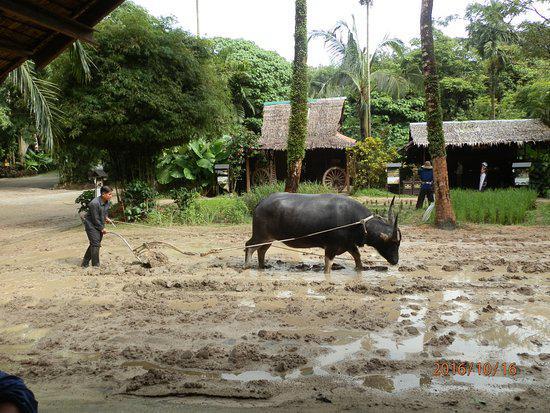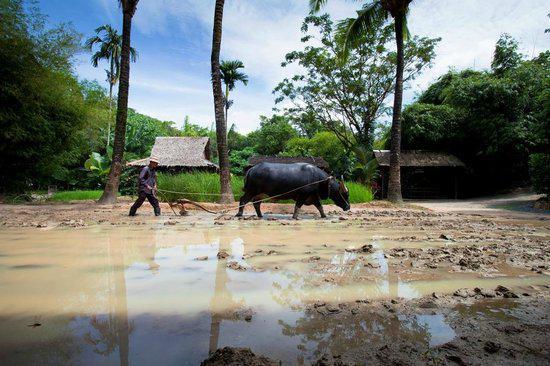The first image is the image on the left, the second image is the image on the right. Given the left and right images, does the statement "There are two horned ox pulling a til held by a man with a white long sleeve shirt and ball cap." hold true? Answer yes or no. No. 